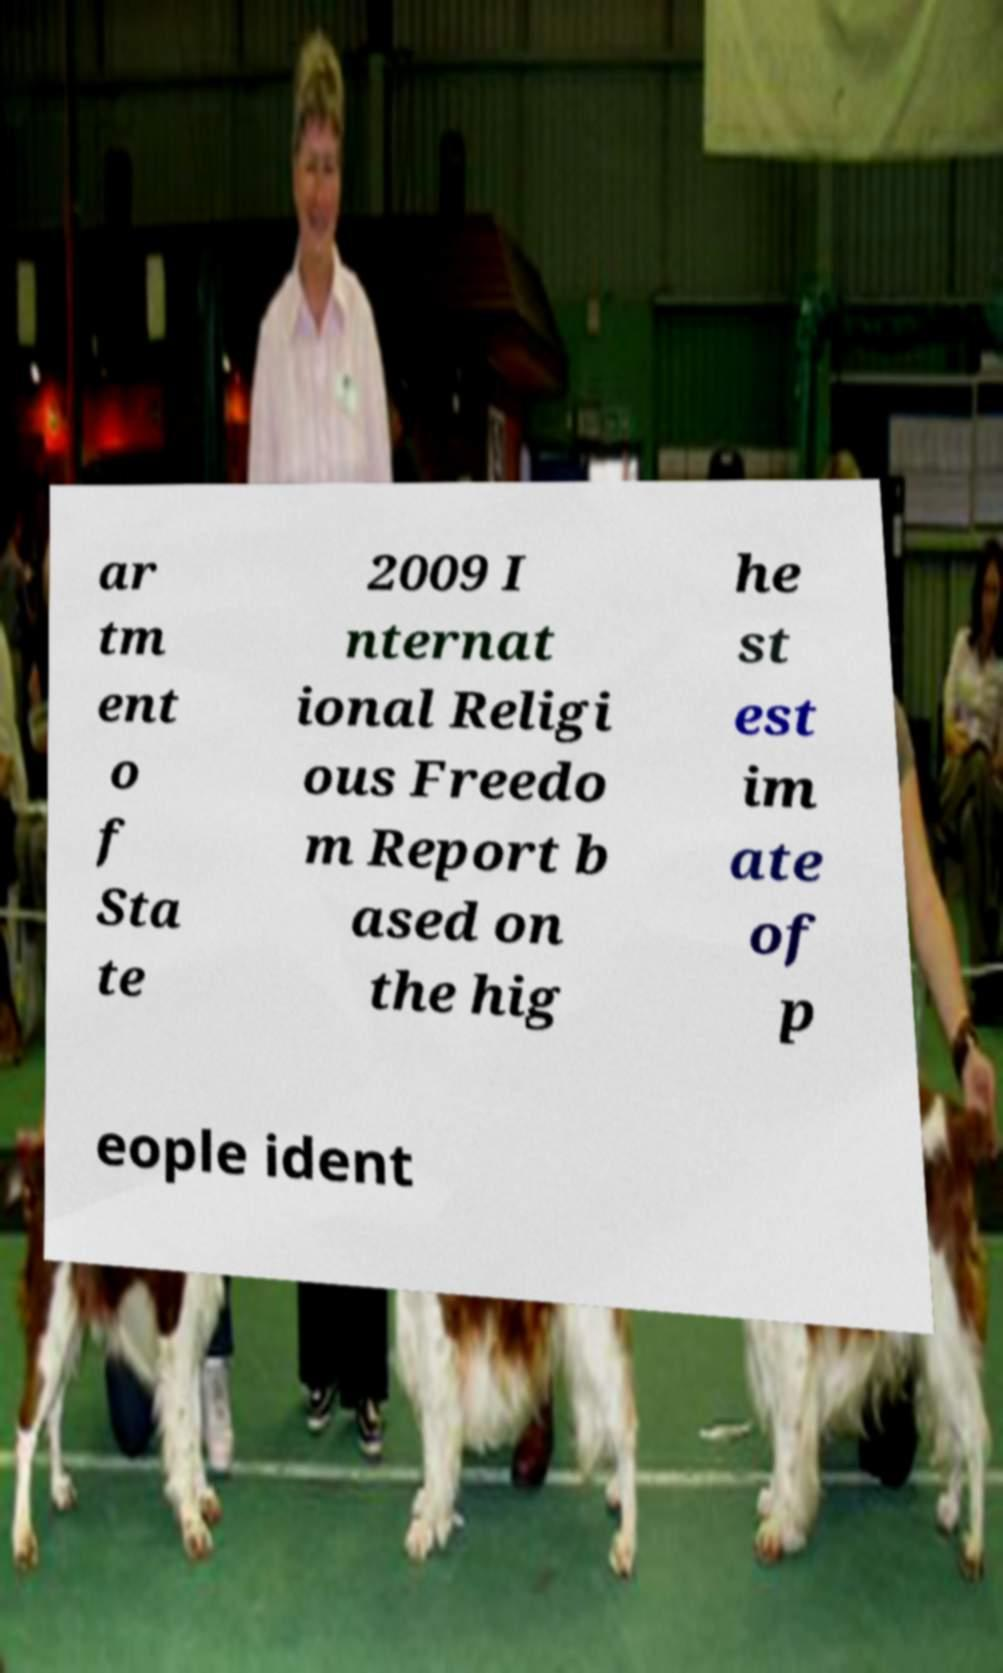What messages or text are displayed in this image? I need them in a readable, typed format. ar tm ent o f Sta te 2009 I nternat ional Religi ous Freedo m Report b ased on the hig he st est im ate of p eople ident 